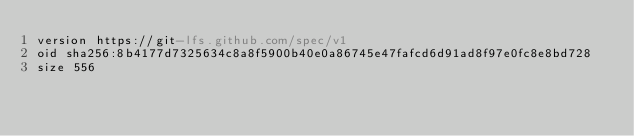<code> <loc_0><loc_0><loc_500><loc_500><_YAML_>version https://git-lfs.github.com/spec/v1
oid sha256:8b4177d7325634c8a8f5900b40e0a86745e47fafcd6d91ad8f97e0fc8e8bd728
size 556
</code> 